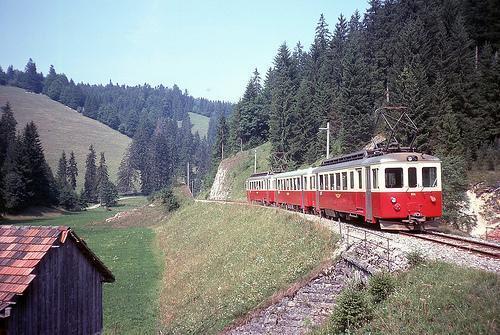How many trains are shown?
Give a very brief answer. 1. 